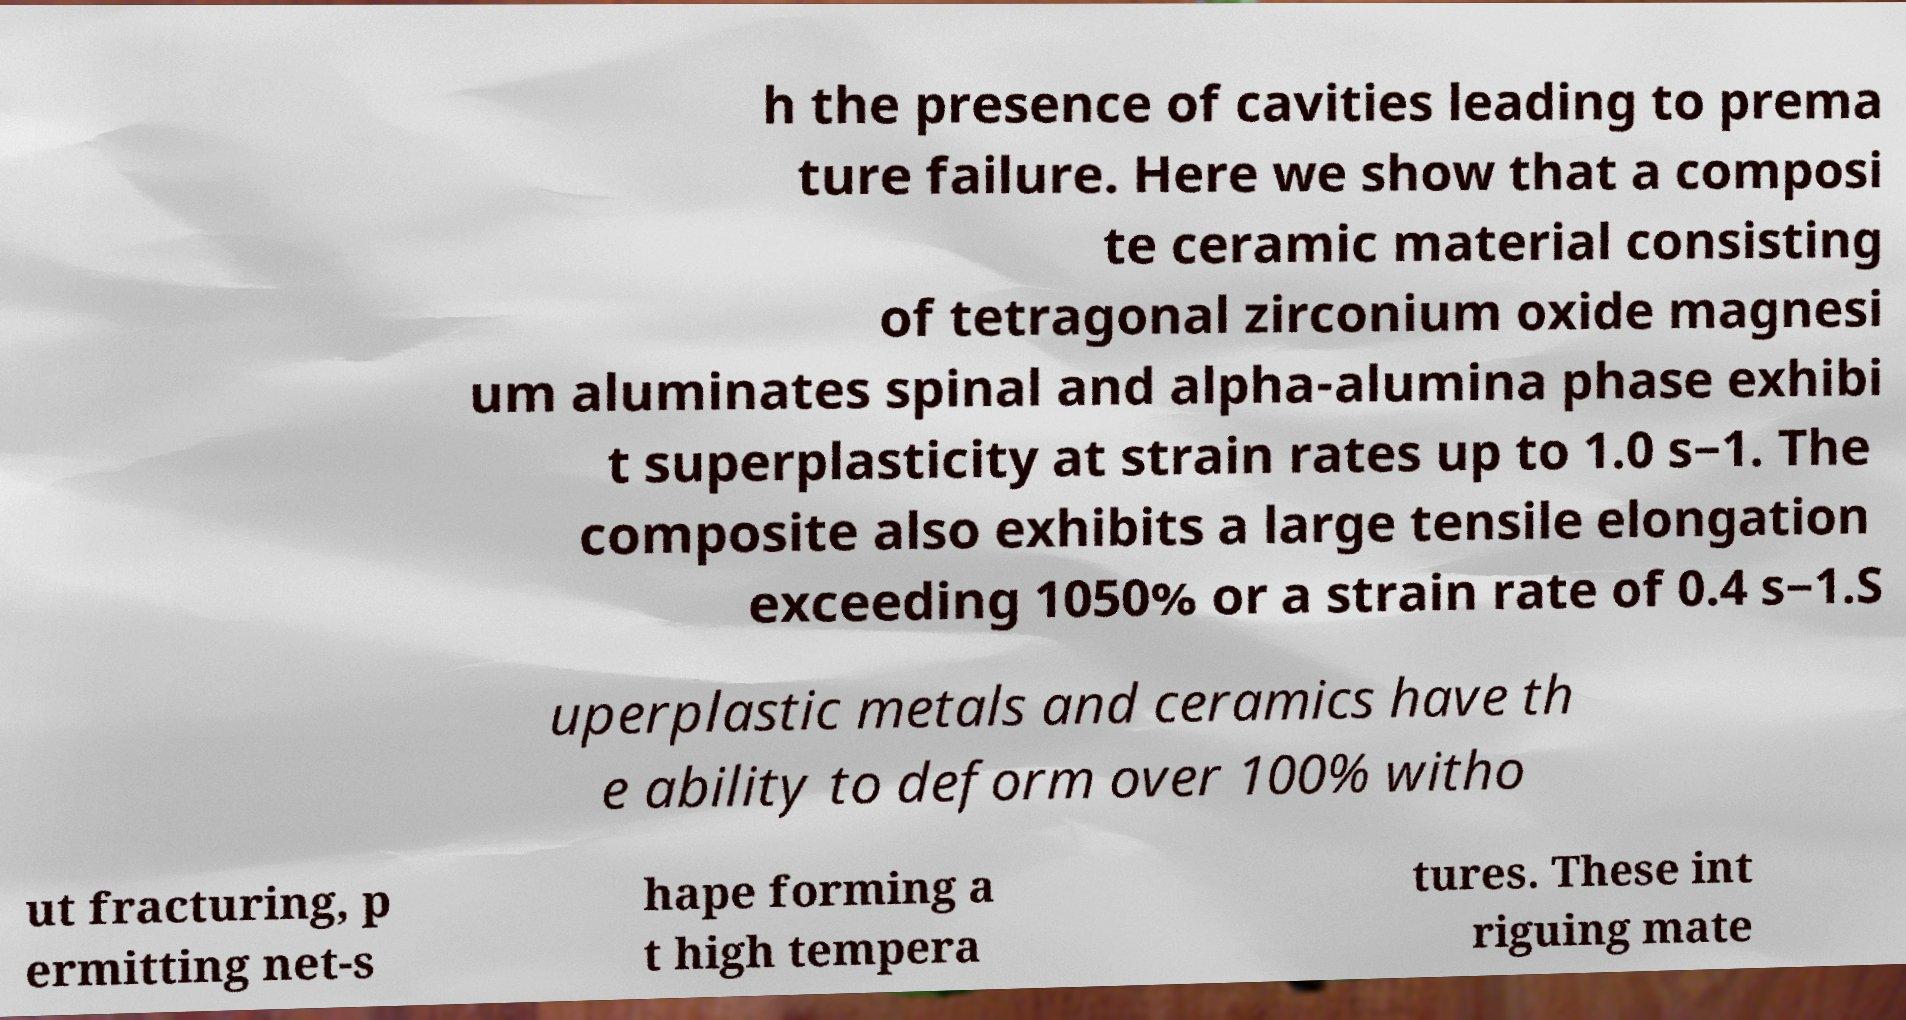There's text embedded in this image that I need extracted. Can you transcribe it verbatim? h the presence of cavities leading to prema ture failure. Here we show that a composi te ceramic material consisting of tetragonal zirconium oxide magnesi um aluminates spinal and alpha-alumina phase exhibi t superplasticity at strain rates up to 1.0 s−1. The composite also exhibits a large tensile elongation exceeding 1050% or a strain rate of 0.4 s−1.S uperplastic metals and ceramics have th e ability to deform over 100% witho ut fracturing, p ermitting net-s hape forming a t high tempera tures. These int riguing mate 